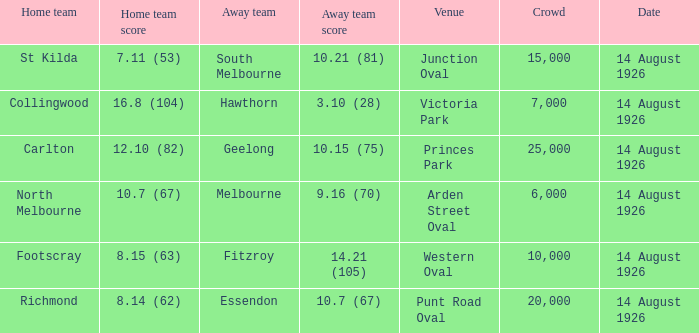What is the combined number of all the fans that attended north melbourne at home? 6000.0. 